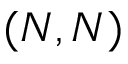Convert formula to latex. <formula><loc_0><loc_0><loc_500><loc_500>( N , N )</formula> 